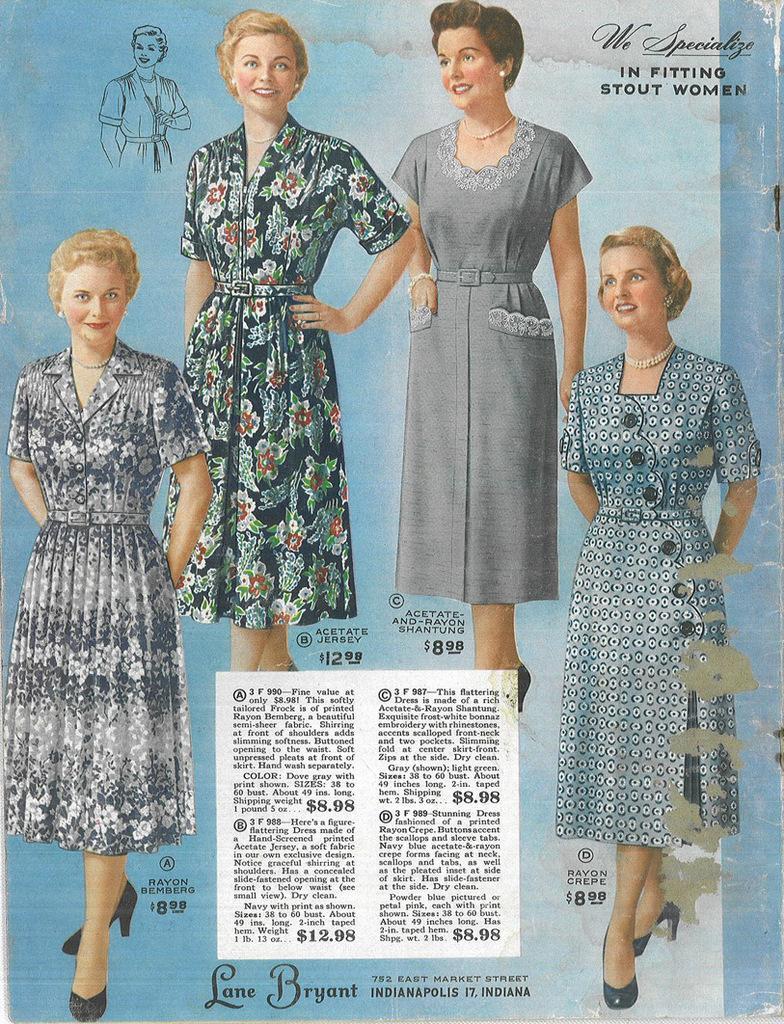How would you summarize this image in a sentence or two? In this picture I can see a poster with some text and few woman standing and I can see text at the top right corner and at the bottom of the picture. 